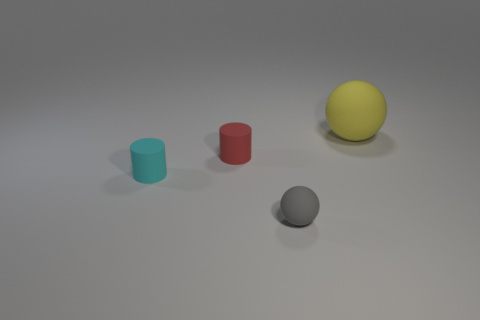Add 4 red matte objects. How many objects exist? 8 Subtract all red cylinders. Subtract all cyan spheres. How many cylinders are left? 1 Subtract 1 gray spheres. How many objects are left? 3 Subtract all big yellow balls. Subtract all yellow objects. How many objects are left? 2 Add 2 tiny rubber objects. How many tiny rubber objects are left? 5 Add 4 big yellow rubber balls. How many big yellow rubber balls exist? 5 